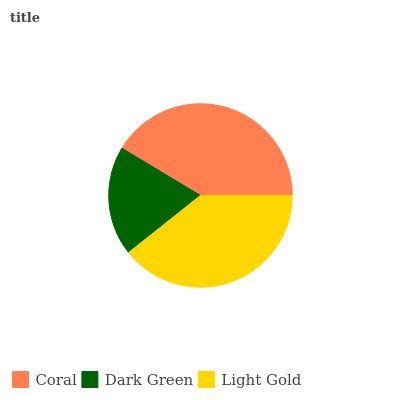Is Dark Green the minimum?
Answer yes or no. Yes. Is Coral the maximum?
Answer yes or no. Yes. Is Light Gold the minimum?
Answer yes or no. No. Is Light Gold the maximum?
Answer yes or no. No. Is Light Gold greater than Dark Green?
Answer yes or no. Yes. Is Dark Green less than Light Gold?
Answer yes or no. Yes. Is Dark Green greater than Light Gold?
Answer yes or no. No. Is Light Gold less than Dark Green?
Answer yes or no. No. Is Light Gold the high median?
Answer yes or no. Yes. Is Light Gold the low median?
Answer yes or no. Yes. Is Coral the high median?
Answer yes or no. No. Is Coral the low median?
Answer yes or no. No. 